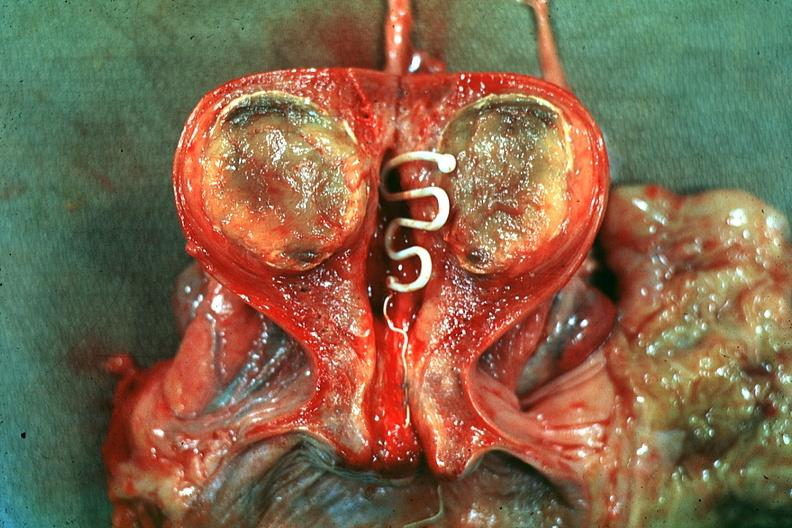where does this belong to?
Answer the question using a single word or phrase. Female reproductive system 